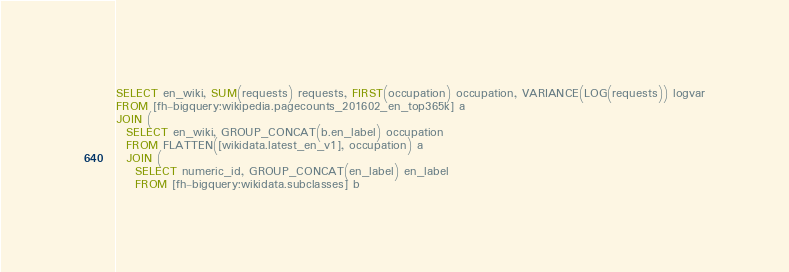<code> <loc_0><loc_0><loc_500><loc_500><_SQL_>SELECT en_wiki, SUM(requests) requests, FIRST(occupation) occupation, VARIANCE(LOG(requests)) logvar
FROM [fh-bigquery:wikipedia.pagecounts_201602_en_top365k] a 
JOIN (
  SELECT en_wiki, GROUP_CONCAT(b.en_label) occupation
  FROM FLATTEN([wikidata.latest_en_v1], occupation) a
  JOIN (
    SELECT numeric_id, GROUP_CONCAT(en_label) en_label
    FROM [fh-bigquery:wikidata.subclasses] b</code> 